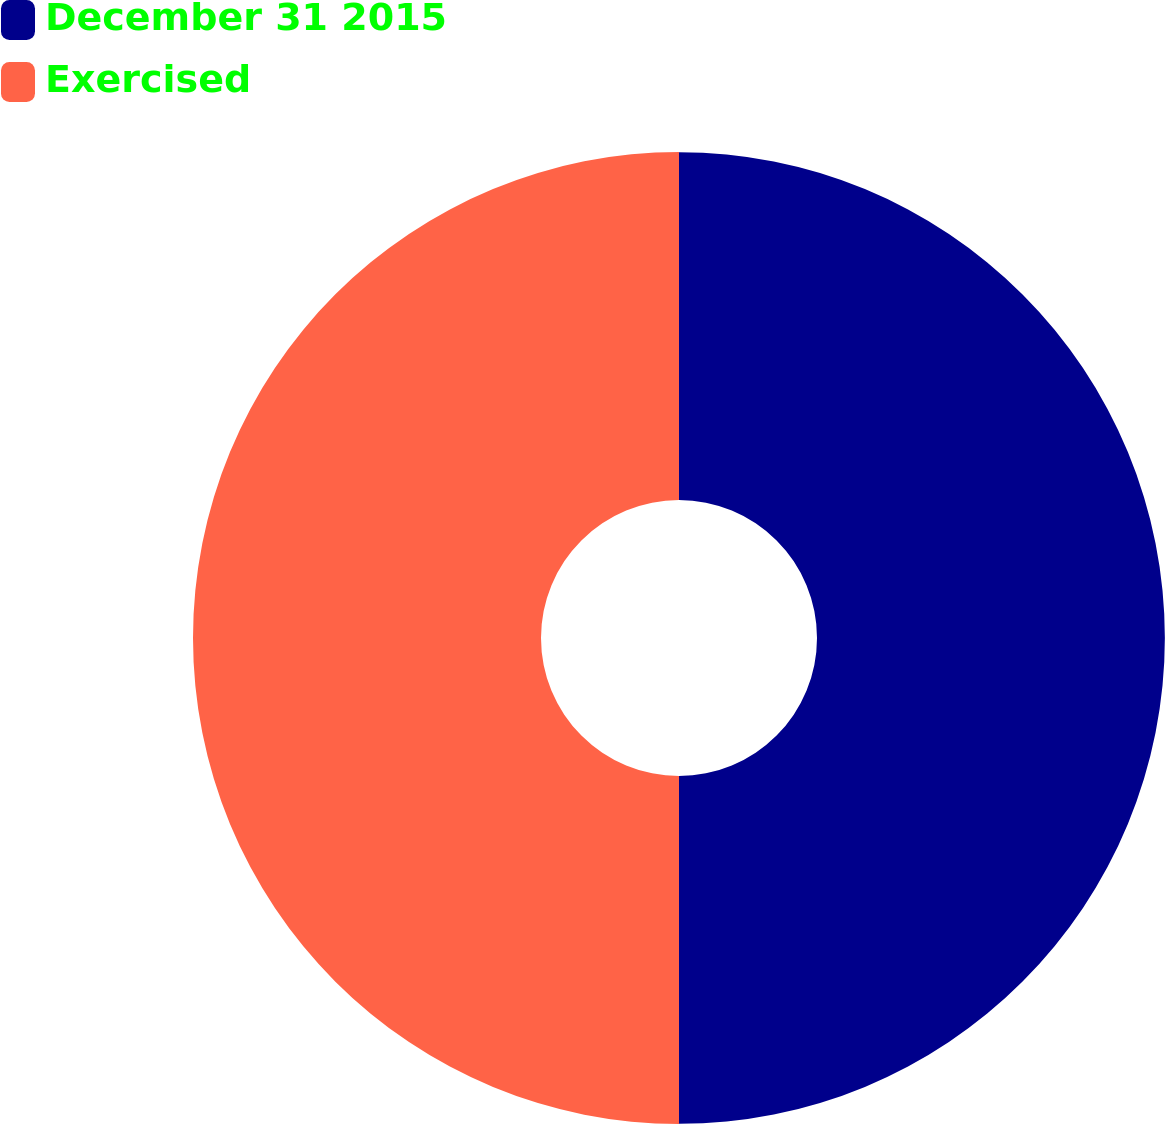Convert chart. <chart><loc_0><loc_0><loc_500><loc_500><pie_chart><fcel>December 31 2015<fcel>Exercised<nl><fcel>49.99%<fcel>50.01%<nl></chart> 